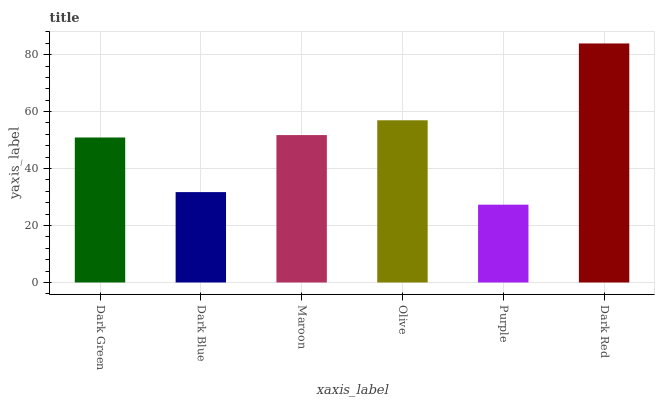Is Purple the minimum?
Answer yes or no. Yes. Is Dark Red the maximum?
Answer yes or no. Yes. Is Dark Blue the minimum?
Answer yes or no. No. Is Dark Blue the maximum?
Answer yes or no. No. Is Dark Green greater than Dark Blue?
Answer yes or no. Yes. Is Dark Blue less than Dark Green?
Answer yes or no. Yes. Is Dark Blue greater than Dark Green?
Answer yes or no. No. Is Dark Green less than Dark Blue?
Answer yes or no. No. Is Maroon the high median?
Answer yes or no. Yes. Is Dark Green the low median?
Answer yes or no. Yes. Is Dark Red the high median?
Answer yes or no. No. Is Dark Red the low median?
Answer yes or no. No. 